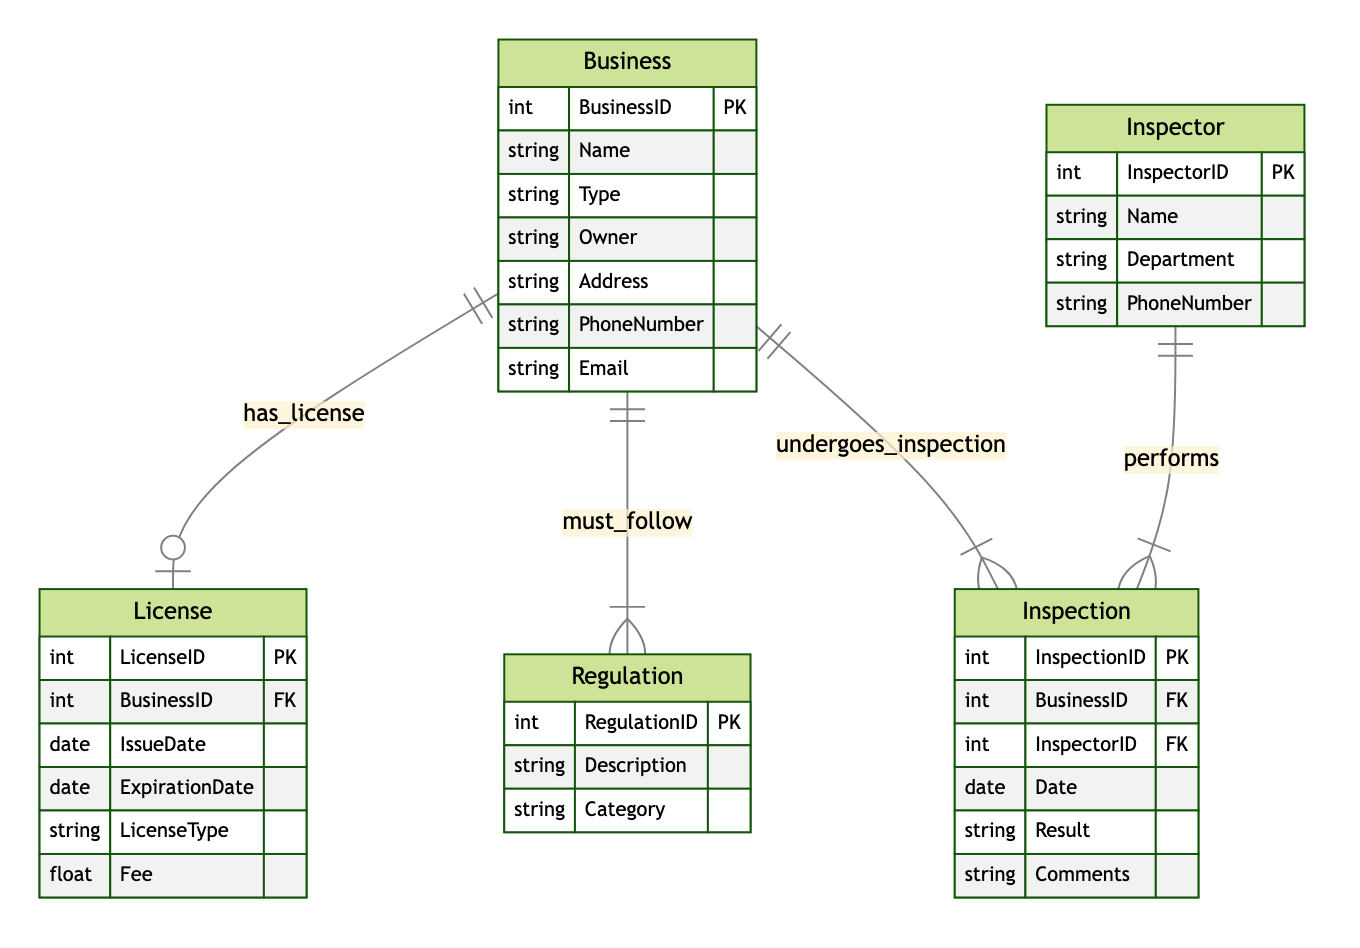What is the primary key of the Business entity? The primary key of the Business entity is BusinessID, which uniquely identifies each business within the diagram. This attribute is specified under the Business entity in the attributes list.
Answer: BusinessID How many types of entities are present in the diagram? There are five types of entities present in the diagram: Business, License, Regulation, Inspection, and Inspector. The number of entities is counted from the provided list of entities.
Answer: Five What is the relationship type between Business and License? The relationship type between Business and License is 1-to-1, which indicates that each business can have exactly one license. This is specified in the relationships section of the data.
Answer: 1-to-1 How many inspections can a single business undergo? A single business can undergo multiple inspections. This is shown by the 1-to-many relationship between Business and Inspection, indicating that one business can have many associated inspections.
Answer: Many What does the Regulation entity describe? The Regulation entity describes the rules each business must follow, with attributes like RegulationID, Description, and Category. The purpose of this entity is to control various business operations.
Answer: Rules Which entity is responsible for performing inspections? The Inspector entity is responsible for performing inspections, as indicated by the performs relationship with the Inspection entity. Each inspector can handle multiple inspections, according to the 1-to-many relationship shown.
Answer: Inspector What attribute connects the License entity to the Business entity? The attribute connecting the License entity to the Business entity is BusinessID, which serves as a foreign key in the License table. This key ensures that each license is associated with a specific business.
Answer: BusinessID How many inspections can an inspector perform? An inspector can perform multiple inspections. This is indicated by the 1-to-many relationship from the Inspector entity to the Inspection entity, which allows one inspector to be assigned to various inspections.
Answer: Many What is the purpose of the Inspection entity? The purpose of the Inspection entity is to record details about the inspections conducted on businesses, including attributes like InspectionID, Date, and Result. This helps track compliance and performance.
Answer: Record inspections 